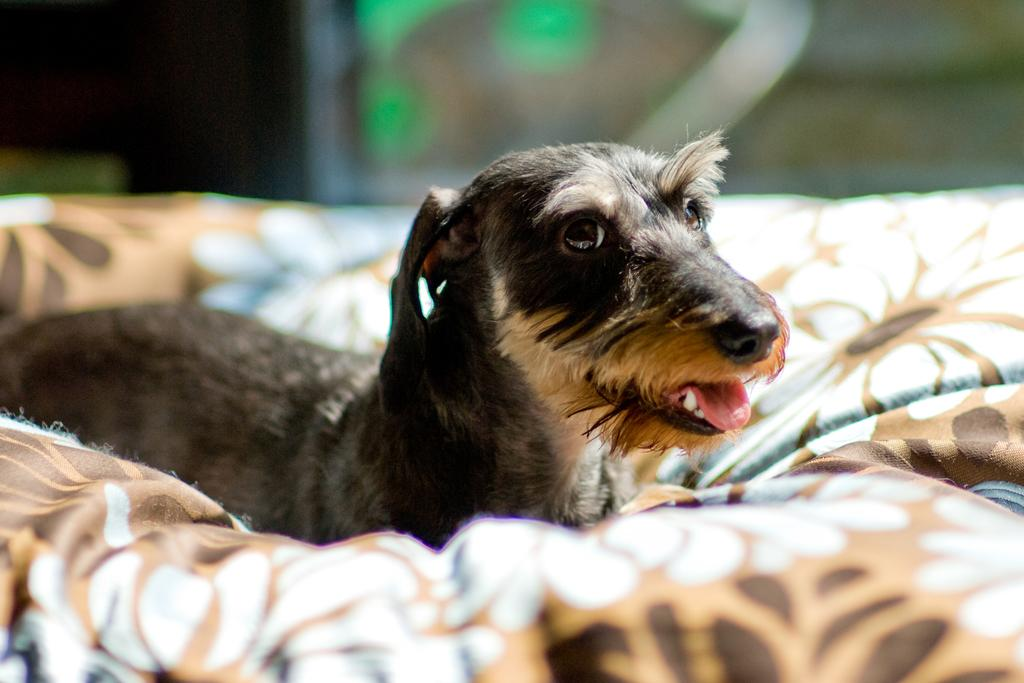What is the main subject in the center of the image? There is a dog in the center of the image. What can be seen at the bottom of the image? There is cloth at the bottom of the image. How many mountains are visible in the image? There are no mountains visible in the image; it features a dog and cloth. Are there any cobwebs present in the image? There are no cobwebs present in the image. 